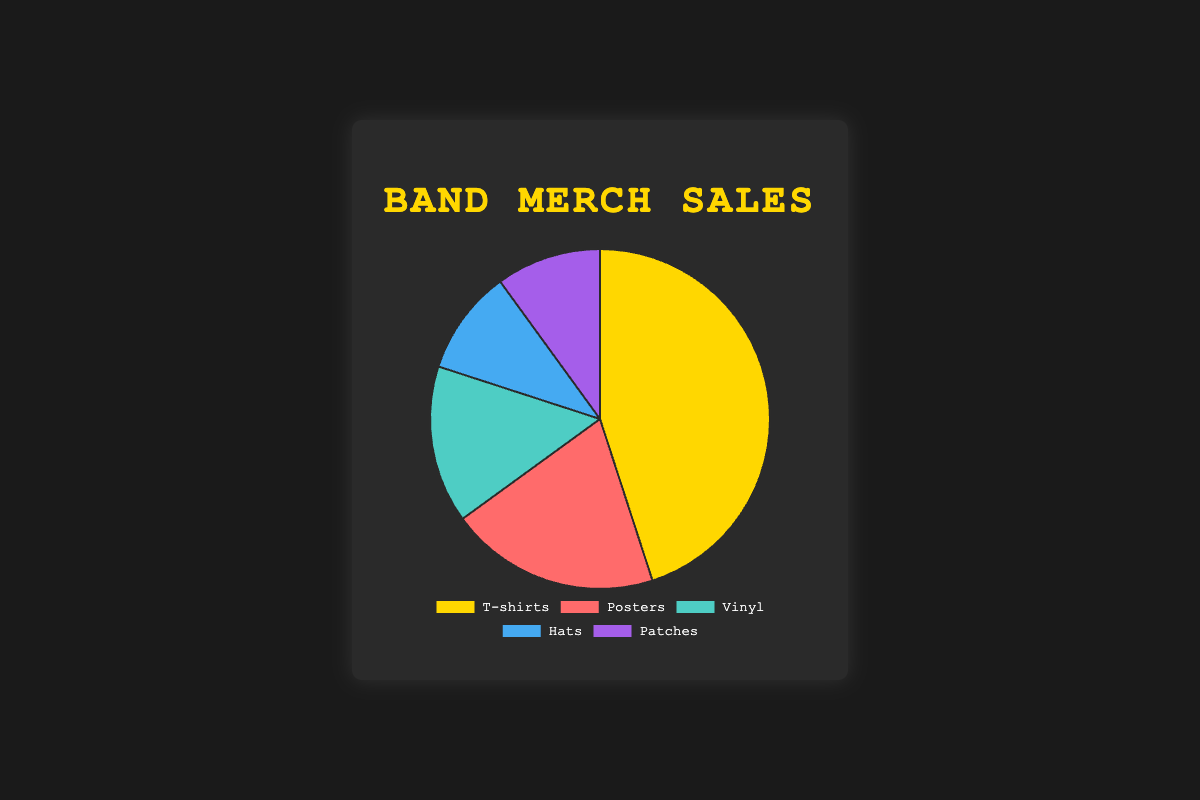What is the best-selling category for band merchandise? The data shows the percentages for each category. The largest percentage corresponds to the T-shirts category. Hence, T-shirts are the best-selling category.
Answer: T-shirts How much more do T-shirts outsell Posters by in terms of percentage? The percentage for T-shirts is 45%, and for Posters, it is 20%. The difference between these percentages is calculated by subtracting 20 from 45, resulting in a difference of 25%.
Answer: 25% What percentage of sales is attributed to Hats and Patches combined? The percentages for Hats and Patches are both 10%. Adding these together gives 10% + 10% = 20%.
Answer: 20% Which category has the smallest share of sales, and what is that share? We compare all percentages: T-shirts (45%), Posters (20%), Vinyl (15%), Hats (10%), and Patches (10%). The smallest share belongs to both Hats and Patches at 10% each.
Answer: Hats and Patches, 10% What is the total percentage of sales for categories other than T-shirts? The total percentage is 100%. Subtracting the percentage for T-shirts (45%) from the total gives 100% - 45% = 55%.
Answer: 55% Compare the sales percentages of Vinyl and Hats. Which one has a larger share and by how much? Vinyl has 15%, and Hats have 10%. Subtracting these gives 15% - 10% = 5%. Therefore, Vinyl has a larger share by 5%.
Answer: Vinyl, 5% How does the percentage of sales for Vinyl compare to the combined sales percentage for Patches and Hats? The percentage for Vinyl is 15%, and the combined sales percentage for Patches and Hats is 10% + 10% = 20%. Vinyl (15%) is less than the combined percentage for Patches and Hats (20%).
Answer: Patches and Hats, 5% Which sales category falls between Posters and Hats in terms of percentage? The percentage for Posters is 20%, and for Hats is 10%. The Vinyl category with 15% falls between these two percentages.
Answer: Vinyl Determine the median percentage value of the sales categories. First, list the sales percentages in ascending order: 10%, 10%, 15%, 20%, 45%. The median value is the middle value, which is 15%.
Answer: 15% What percentage of the sales does the least popular category contribute when compared with the most popular one? The least popular categories are Hats and Patches, each with 10%, and the most popular one is T-shirts with 45%. Calculating the ratio gives (10% / 45%) * 100, which equals approximately 22.2%.
Answer: 22.2% 